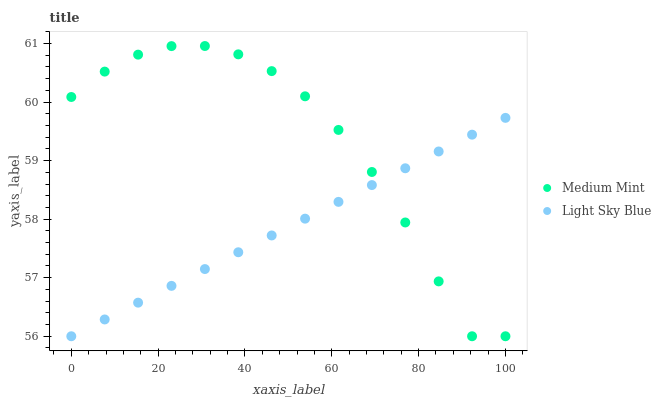Does Light Sky Blue have the minimum area under the curve?
Answer yes or no. Yes. Does Medium Mint have the maximum area under the curve?
Answer yes or no. Yes. Does Light Sky Blue have the maximum area under the curve?
Answer yes or no. No. Is Light Sky Blue the smoothest?
Answer yes or no. Yes. Is Medium Mint the roughest?
Answer yes or no. Yes. Is Light Sky Blue the roughest?
Answer yes or no. No. Does Medium Mint have the lowest value?
Answer yes or no. Yes. Does Medium Mint have the highest value?
Answer yes or no. Yes. Does Light Sky Blue have the highest value?
Answer yes or no. No. Does Medium Mint intersect Light Sky Blue?
Answer yes or no. Yes. Is Medium Mint less than Light Sky Blue?
Answer yes or no. No. Is Medium Mint greater than Light Sky Blue?
Answer yes or no. No. 